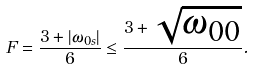Convert formula to latex. <formula><loc_0><loc_0><loc_500><loc_500>F = \frac { 3 + | \omega _ { 0 s } | } { 6 } \leq \frac { 3 + \sqrt { \omega _ { 0 0 } } } { 6 } .</formula> 